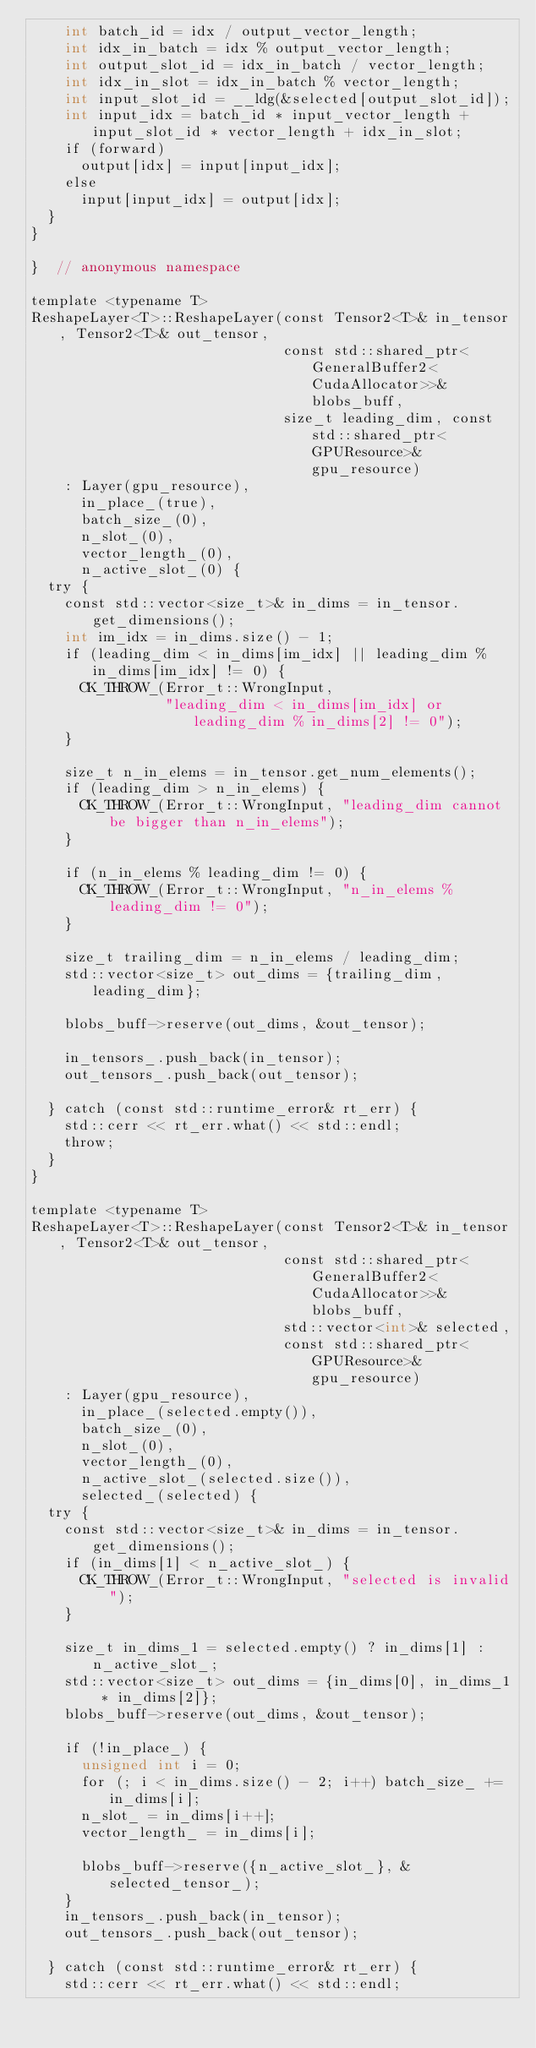<code> <loc_0><loc_0><loc_500><loc_500><_Cuda_>    int batch_id = idx / output_vector_length;
    int idx_in_batch = idx % output_vector_length;
    int output_slot_id = idx_in_batch / vector_length;
    int idx_in_slot = idx_in_batch % vector_length;
    int input_slot_id = __ldg(&selected[output_slot_id]);
    int input_idx = batch_id * input_vector_length + input_slot_id * vector_length + idx_in_slot;
    if (forward)
      output[idx] = input[input_idx];
    else
      input[input_idx] = output[idx];
  }
}

}  // anonymous namespace

template <typename T>
ReshapeLayer<T>::ReshapeLayer(const Tensor2<T>& in_tensor, Tensor2<T>& out_tensor,
                              const std::shared_ptr<GeneralBuffer2<CudaAllocator>>& blobs_buff,
                              size_t leading_dim, const std::shared_ptr<GPUResource>& gpu_resource)
    : Layer(gpu_resource),
      in_place_(true),
      batch_size_(0),
      n_slot_(0),
      vector_length_(0),
      n_active_slot_(0) {
  try {
    const std::vector<size_t>& in_dims = in_tensor.get_dimensions();
    int im_idx = in_dims.size() - 1;
    if (leading_dim < in_dims[im_idx] || leading_dim % in_dims[im_idx] != 0) {
      CK_THROW_(Error_t::WrongInput,
                "leading_dim < in_dims[im_idx] or leading_dim % in_dims[2] != 0");
    }

    size_t n_in_elems = in_tensor.get_num_elements();
    if (leading_dim > n_in_elems) {
      CK_THROW_(Error_t::WrongInput, "leading_dim cannot be bigger than n_in_elems");
    }

    if (n_in_elems % leading_dim != 0) {
      CK_THROW_(Error_t::WrongInput, "n_in_elems % leading_dim != 0");
    }

    size_t trailing_dim = n_in_elems / leading_dim;
    std::vector<size_t> out_dims = {trailing_dim, leading_dim};

    blobs_buff->reserve(out_dims, &out_tensor);

    in_tensors_.push_back(in_tensor);
    out_tensors_.push_back(out_tensor);

  } catch (const std::runtime_error& rt_err) {
    std::cerr << rt_err.what() << std::endl;
    throw;
  }
}

template <typename T>
ReshapeLayer<T>::ReshapeLayer(const Tensor2<T>& in_tensor, Tensor2<T>& out_tensor,
                              const std::shared_ptr<GeneralBuffer2<CudaAllocator>>& blobs_buff,
                              std::vector<int>& selected,
                              const std::shared_ptr<GPUResource>& gpu_resource)
    : Layer(gpu_resource),
      in_place_(selected.empty()),
      batch_size_(0),
      n_slot_(0),
      vector_length_(0),
      n_active_slot_(selected.size()),
      selected_(selected) {
  try {
    const std::vector<size_t>& in_dims = in_tensor.get_dimensions();
    if (in_dims[1] < n_active_slot_) {
      CK_THROW_(Error_t::WrongInput, "selected is invalid");
    }

    size_t in_dims_1 = selected.empty() ? in_dims[1] : n_active_slot_;
    std::vector<size_t> out_dims = {in_dims[0], in_dims_1 * in_dims[2]};
    blobs_buff->reserve(out_dims, &out_tensor);

    if (!in_place_) {
      unsigned int i = 0;
      for (; i < in_dims.size() - 2; i++) batch_size_ += in_dims[i];
      n_slot_ = in_dims[i++];
      vector_length_ = in_dims[i];

      blobs_buff->reserve({n_active_slot_}, &selected_tensor_);
    }
    in_tensors_.push_back(in_tensor);
    out_tensors_.push_back(out_tensor);

  } catch (const std::runtime_error& rt_err) {
    std::cerr << rt_err.what() << std::endl;</code> 